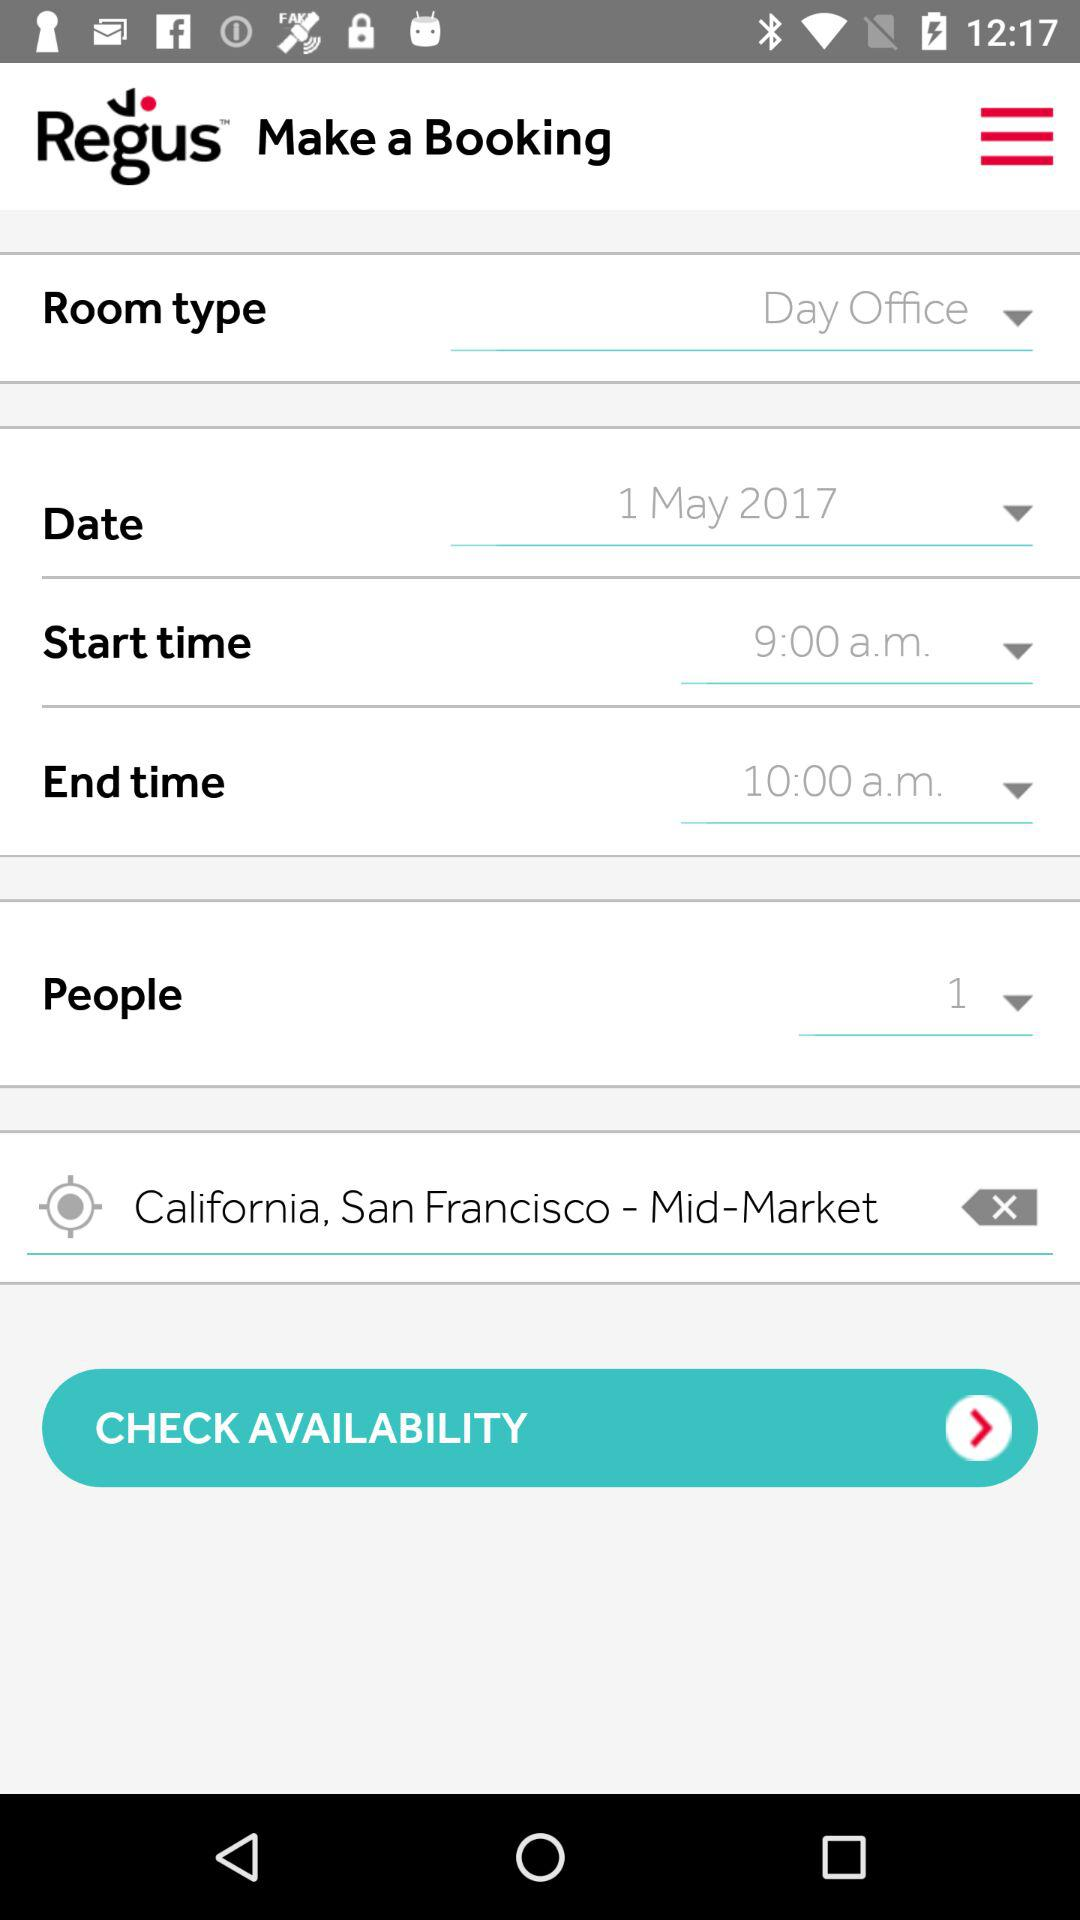What is the location? The location is Mid-Market, San Francisco, California. 